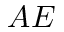Convert formula to latex. <formula><loc_0><loc_0><loc_500><loc_500>A E</formula> 